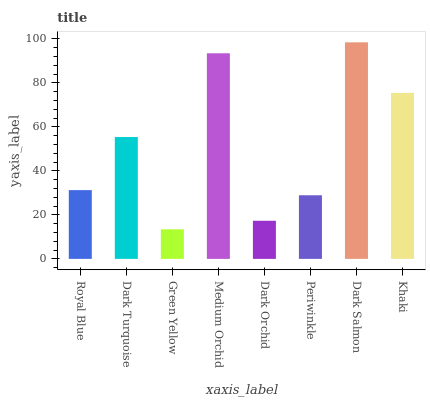Is Green Yellow the minimum?
Answer yes or no. Yes. Is Dark Salmon the maximum?
Answer yes or no. Yes. Is Dark Turquoise the minimum?
Answer yes or no. No. Is Dark Turquoise the maximum?
Answer yes or no. No. Is Dark Turquoise greater than Royal Blue?
Answer yes or no. Yes. Is Royal Blue less than Dark Turquoise?
Answer yes or no. Yes. Is Royal Blue greater than Dark Turquoise?
Answer yes or no. No. Is Dark Turquoise less than Royal Blue?
Answer yes or no. No. Is Dark Turquoise the high median?
Answer yes or no. Yes. Is Royal Blue the low median?
Answer yes or no. Yes. Is Green Yellow the high median?
Answer yes or no. No. Is Dark Orchid the low median?
Answer yes or no. No. 